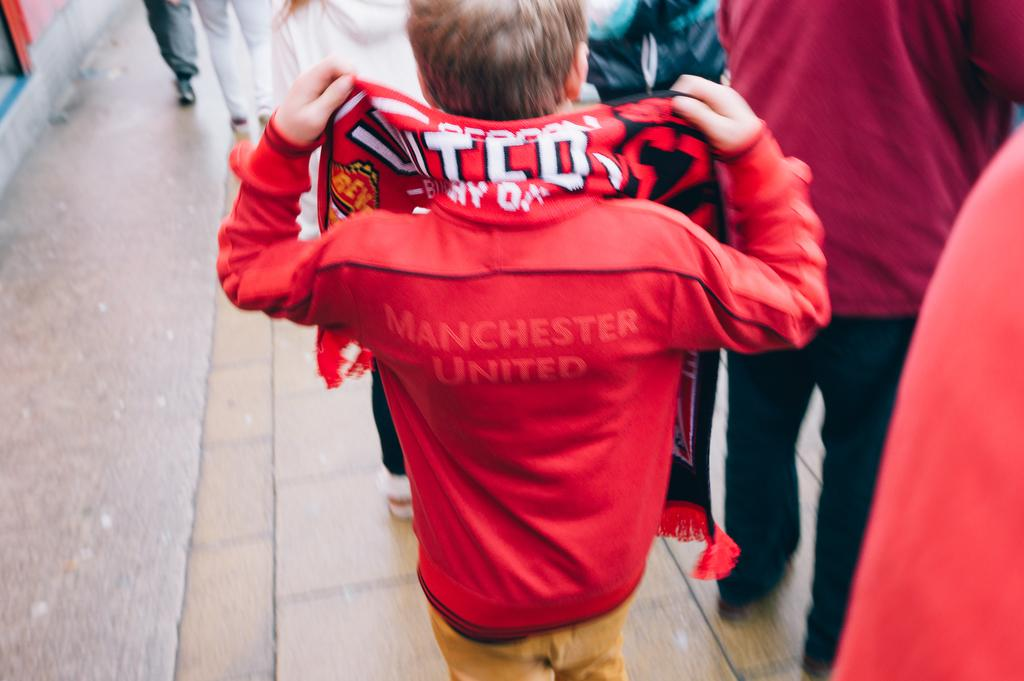<image>
Provide a brief description of the given image. A boy has "Manchester United" on the back of his jacket. 